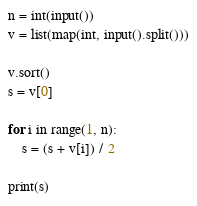<code> <loc_0><loc_0><loc_500><loc_500><_Python_>n = int(input())
v = list(map(int, input().split()))

v.sort()
s = v[0]

for i in range(1, n):
    s = (s + v[i]) / 2

print(s)</code> 